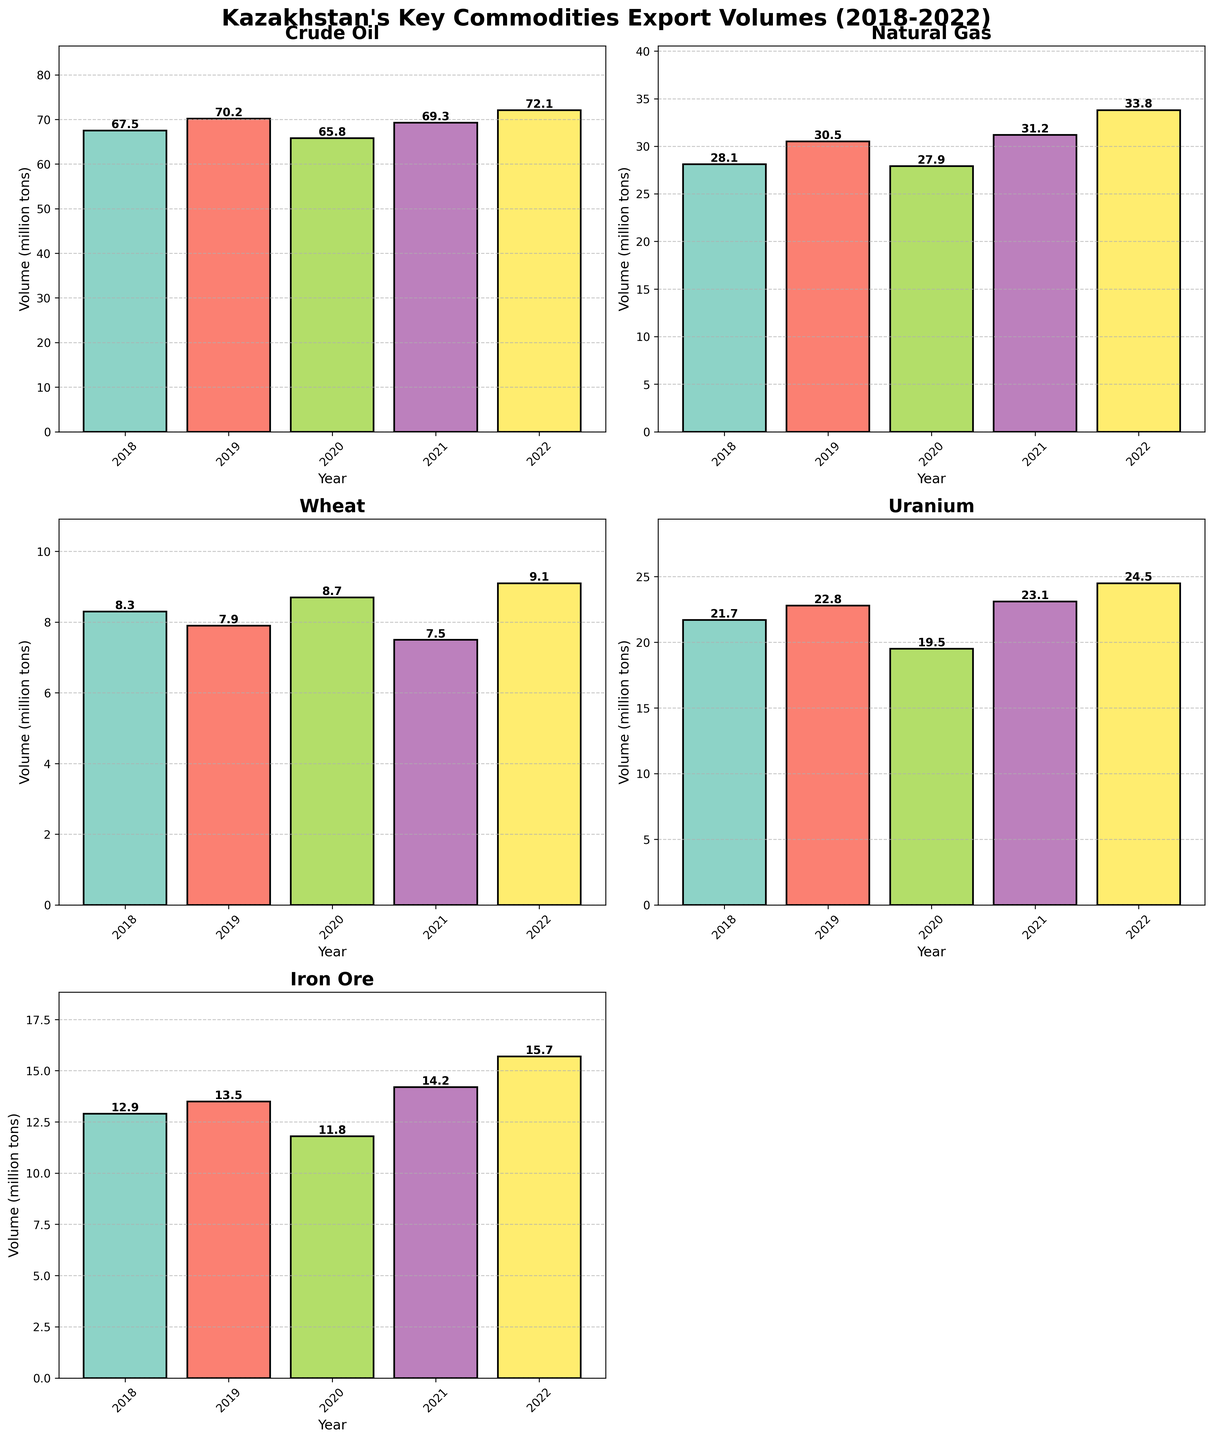what is the overall trend for Crude Oil export volumes from 2018 to 2022? To determine the overall trend, observe the export volumes for Crude Oil over the years. The volume increases from 67.5 in 2018 to 72.1 in 2022, with minor fluctuations.
Answer: Increasing trend what is the title of the figure? The title is located at the top center of the figure. It reads "Kazakhstan's Key Commodities Export Volumes (2018-2022)"
Answer: Kazakhstan's Key Commodities Export Volumes (2018-2022) how many years are displayed on the x-axis? The years displayed on the x-axis are 2018, 2019, 2020, 2021, and 2022. Count them to find there are 5 years.
Answer: 5 which commodity had the highest export volume in 2022? Look across all the subplots for the year 2022. The highest bar is for Crude Oil at 72.1 million tons.
Answer: Crude Oil how does the volume of Wheat exports in 2020 compare to 2018? Find the Wheat export volumes for both years and compare. It was 8.7 million tons in 2020 and 8.3 million tons in 2018.
Answer: Higher in 2020 what is the average export volume of Natural Gas over the 5 years? Sum the export volumes from 2018 to 2022 (28.1 + 30.5 + 27.9 + 31.2 + 33.8 = 151.5) and divide by 5. The average is 151.5 / 5.
Answer: 30.3 which year had the lowest Iron Ore export volume? Compare the Iron Ore export volumes across all years. The lowest value is in 2020 at 11.8 million tons.
Answer: 2020 for which commodities did the export volume increase every year from 2018 to 2022? Check each year's volume for every commodity. Natural Gas and Uranium show a consistent increase every year.
Answer: Natural Gas and Uranium what is the difference in Crude Oil export volumes between the highest and lowest years? The highest volume is 72.1 in 2022 and the lowest is 65.8 in 2020. The difference is 72.1 - 65.8
Answer: 6.3 which commodity had the greatest increase in export volume between 2018 and 2022? Calculate the difference between 2022 and 2018 volumes for each commodity. The greatest difference is for Crude Oil (72.1 - 67.5 = 4.6).
Answer: Crude Oil 